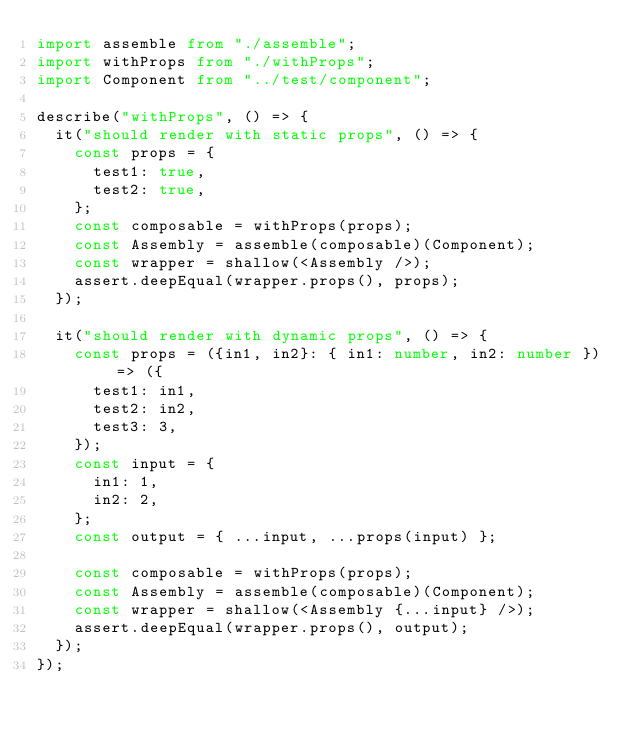<code> <loc_0><loc_0><loc_500><loc_500><_TypeScript_>import assemble from "./assemble";
import withProps from "./withProps";
import Component from "../test/component";

describe("withProps", () => {
  it("should render with static props", () => {
    const props = {
      test1: true,
      test2: true,
    };
    const composable = withProps(props);
    const Assembly = assemble(composable)(Component);
    const wrapper = shallow(<Assembly />);
    assert.deepEqual(wrapper.props(), props);
  });

  it("should render with dynamic props", () => {
    const props = ({in1, in2}: { in1: number, in2: number }) => ({
      test1: in1,
      test2: in2,
      test3: 3,
    });
    const input = {
      in1: 1,
      in2: 2,
    };
    const output = { ...input, ...props(input) };

    const composable = withProps(props);
    const Assembly = assemble(composable)(Component);
    const wrapper = shallow(<Assembly {...input} />);
    assert.deepEqual(wrapper.props(), output);
  });
});
</code> 